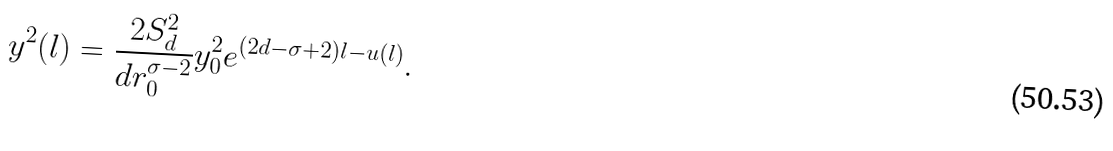<formula> <loc_0><loc_0><loc_500><loc_500>y ^ { 2 } ( l ) = \frac { 2 S _ { d } ^ { 2 } } { d r _ { 0 } ^ { \sigma - 2 } } y _ { 0 } ^ { 2 } e ^ { ( 2 d - \sigma + 2 ) l - u ( l ) } .</formula> 